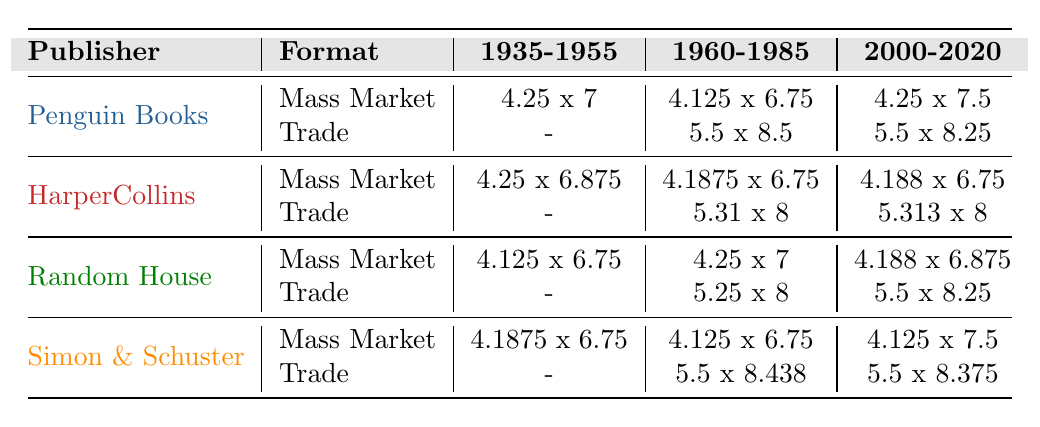What are the dimensions of the Trade Paperback format for Penguin Books in 2020? The table shows that for Penguin Books, the Trade Paperback size in 2020 is 5.5 x 8.25 inches.
Answer: 5.5 x 8.25 inches Which publisher had a Mass Market Paperback size of 4.25 x 7 inches in 1960? According to the table, Penguin Books had a Mass Market Paperback size of 4.25 x 7 inches in 1960.
Answer: Penguin Books Is the Mass Market Paperback size of HarperCollins in 2010 different from that of Random House in 2005? Yes, HarperCollins had a Mass Market Paperback size of 4.188 x 6.75 inches in 2010, while Random House had a size of 4.188 x 6.875 inches in 2005.
Answer: Yes What is the difference in sizes between the Trade Paperback formats of Simon & Schuster from 2000 to 2020? In 2000, Simon & Schuster's Trade Paperback size was 5.5 x 8.25 inches, and in 2020 it was 5.5 x 8.375 inches. The difference in height is 0.125 inches.
Answer: 0.125 inches difference For which years did Random House produce a Mass Market Paperback that was larger than 4.25 x 7 inches? Examining the table, Random House's Mass Market Paperback size was 4.125 x 6.75 inches in 1945 and 4.25 x 7 inches in 1975. The only size larger would be 4.188 x 6.875 inches in 2005. This indicates they only produced one larger size from 1945 until 2005.
Answer: 2005 What is the trend in the size of Mass Market Paperbacks from HarperCollins from 1950 to 2010? The sizes show a slight decrease in width from 4.25 x 6.875 inches in 1950 to 4.188 x 6.75 in 2010, indicating a trend of decreasing width in their Mass Market Paperbacks over the years.
Answer: Decreasing width trend Which publishing house maintained the same Mass Market Paperback size from 1985 to 2015? The table indicates that Simon & Schuster maintained a Mass Market Paperback size of 4.125 x 6.75 inches from 1985 until 2015.
Answer: Simon & Schuster Compare the Trade Paperback size of Random House in 2018 with that of Penguin Books in 2020. Random House's Trade Paperback size in 2018 is 5.5 x 8.25 inches, and Penguin Books's size in 2020 is also 5.5 x 8.25 inches, indicating they are the same size.
Answer: Same size Which publisher had the largest size for Mass Market Paperback in the year 2000? The Mass Market Paperback size for Penguin Books in 2000 was 4.25 x 7.5 inches, which is larger compared to the sizes listed for other publishers for that year.
Answer: Penguin Books Is it true that all Trade Paperbacks from Random House in the years listed are larger than those from HarperCollins? No, Random House's Trade Paperback sizes are 5.25 x 8 inches in 1960, 5.5 x 8.25 inches in 1985, and 5.5 x 8.25 inches in 2018, while HarperCollins had sizes of 5.31 x 8 inches in 1970 and 5.313 x 8 inches in 2015. The sizes from both publishers overlap and are not consistently larger for Random House.
Answer: No 